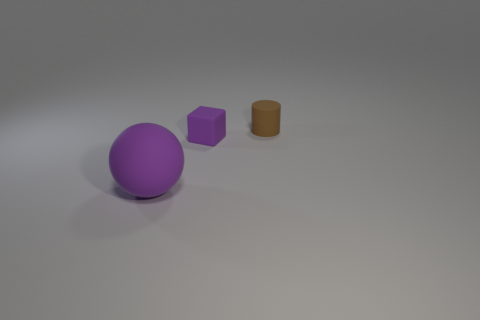Are there fewer small rubber things behind the small purple matte thing than red metal cubes?
Make the answer very short. No. There is a tiny cylinder that is the same material as the big purple object; what is its color?
Provide a succinct answer. Brown. Is the number of small purple rubber cubes that are behind the purple rubber ball less than the number of objects that are to the left of the cylinder?
Keep it short and to the point. Yes. Do the tiny thing that is in front of the small brown rubber cylinder and the matte thing on the left side of the tiny purple thing have the same color?
Ensure brevity in your answer.  Yes. Is there a brown thing that has the same material as the small cube?
Provide a short and direct response. Yes. What is the size of the matte object to the right of the small object on the left side of the tiny cylinder?
Your response must be concise. Small. Is the number of blocks greater than the number of big gray metallic blocks?
Your response must be concise. Yes. Does the thing that is left of the block have the same size as the small brown rubber thing?
Give a very brief answer. No. What number of cylinders have the same color as the ball?
Your response must be concise. 0. Does the brown rubber thing have the same shape as the tiny purple object?
Ensure brevity in your answer.  No. 